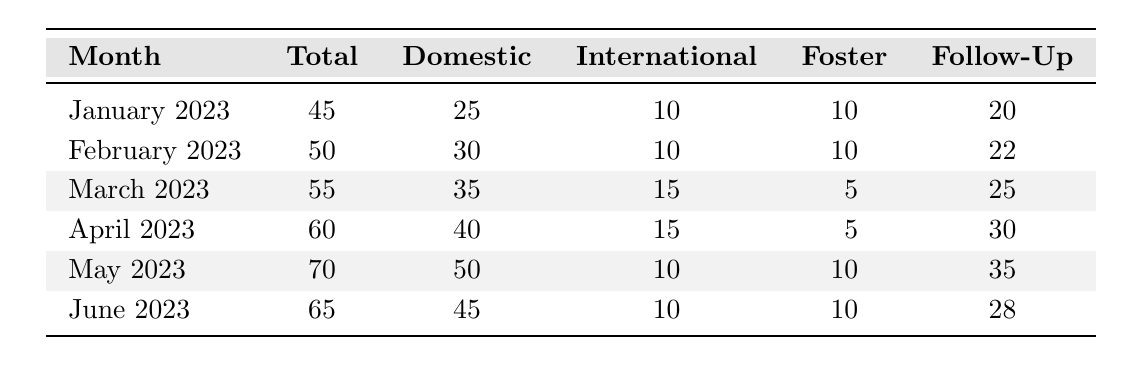What was the highest number of inquiries received in a single month? The highest number of inquiries can be found by looking at the "Total" column. Comparing the totals for each month, June 2023 has the second highest at 65, while May 2023 has the highest at 70.
Answer: 70 In which month were the fewest inquiries for foster care received? By checking the "Foster" column for each month, the data shows that March and April both have the lowest number of foster care inquiries recorded at 5 each.
Answer: 5 What is the average number of follow-up inquiries received in the first half of 2023? To find the average, sum the follow-up inquiries: (20 + 22 + 25 + 30 + 35 + 28) = 160. Then divide by the 6 months, which gives 160 / 6 = approximately 26.67.
Answer: 26.67 Which month saw the largest increase in total inquiries compared to the previous month? To find the month with the largest increase, calculate the difference between the total inquiries for each consecutive month: January to February (50-45=5), February to March (55-50=5), March to April (60-55=5), April to May (70-60=10), May to June (65-70=-5). The largest increase occurs from April to May, with an increase of 10 inquiries.
Answer: April to May How many more domestic adoption inquiries were received in May than in January? By comparing the "Domestic" column, January had 25 domestic adoption inquiries, while May had 50. The difference is 50 - 25 = 25.
Answer: 25 Is it true that the total inquiries decreased from May to June? By comparing the "Total" column, May shows 70 inquiries and June shows 65 inquiries. Since 65 is less than 70, it confirms that there was indeed a decrease in inquiries.
Answer: Yes What percentage of total inquiries in April were for international adoption? For April, the total inquiries were 60 and international adoption inquiries were 15. The percentage is calculated as (15 / 60) * 100 = 25%.
Answer: 25% Which type of inquiry had the most significant increase from February to April? The number of domestic inquiries increased from 30 in February to 40 in April, which is an increase of 10. International inquiries increased by 5 (from 10 to 15), and foster care remained constant. Thus, domestic adoption had the most significant increase.
Answer: Domestic Adoption 